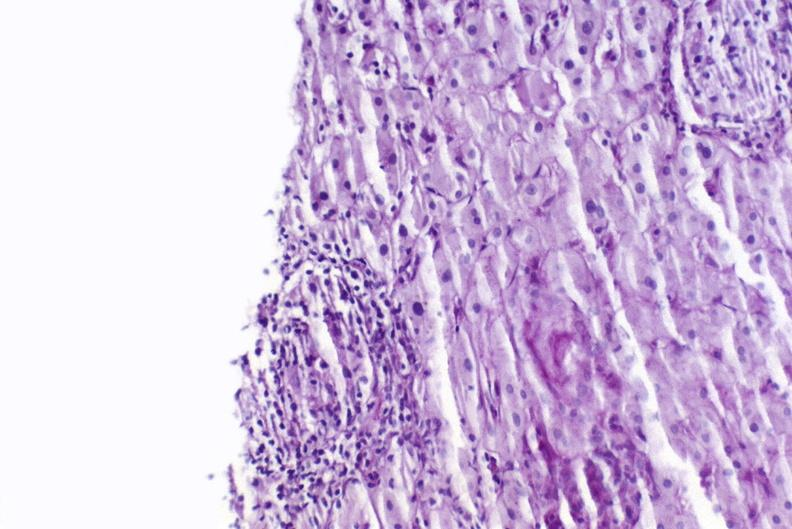does this image show sarcoid?
Answer the question using a single word or phrase. Yes 